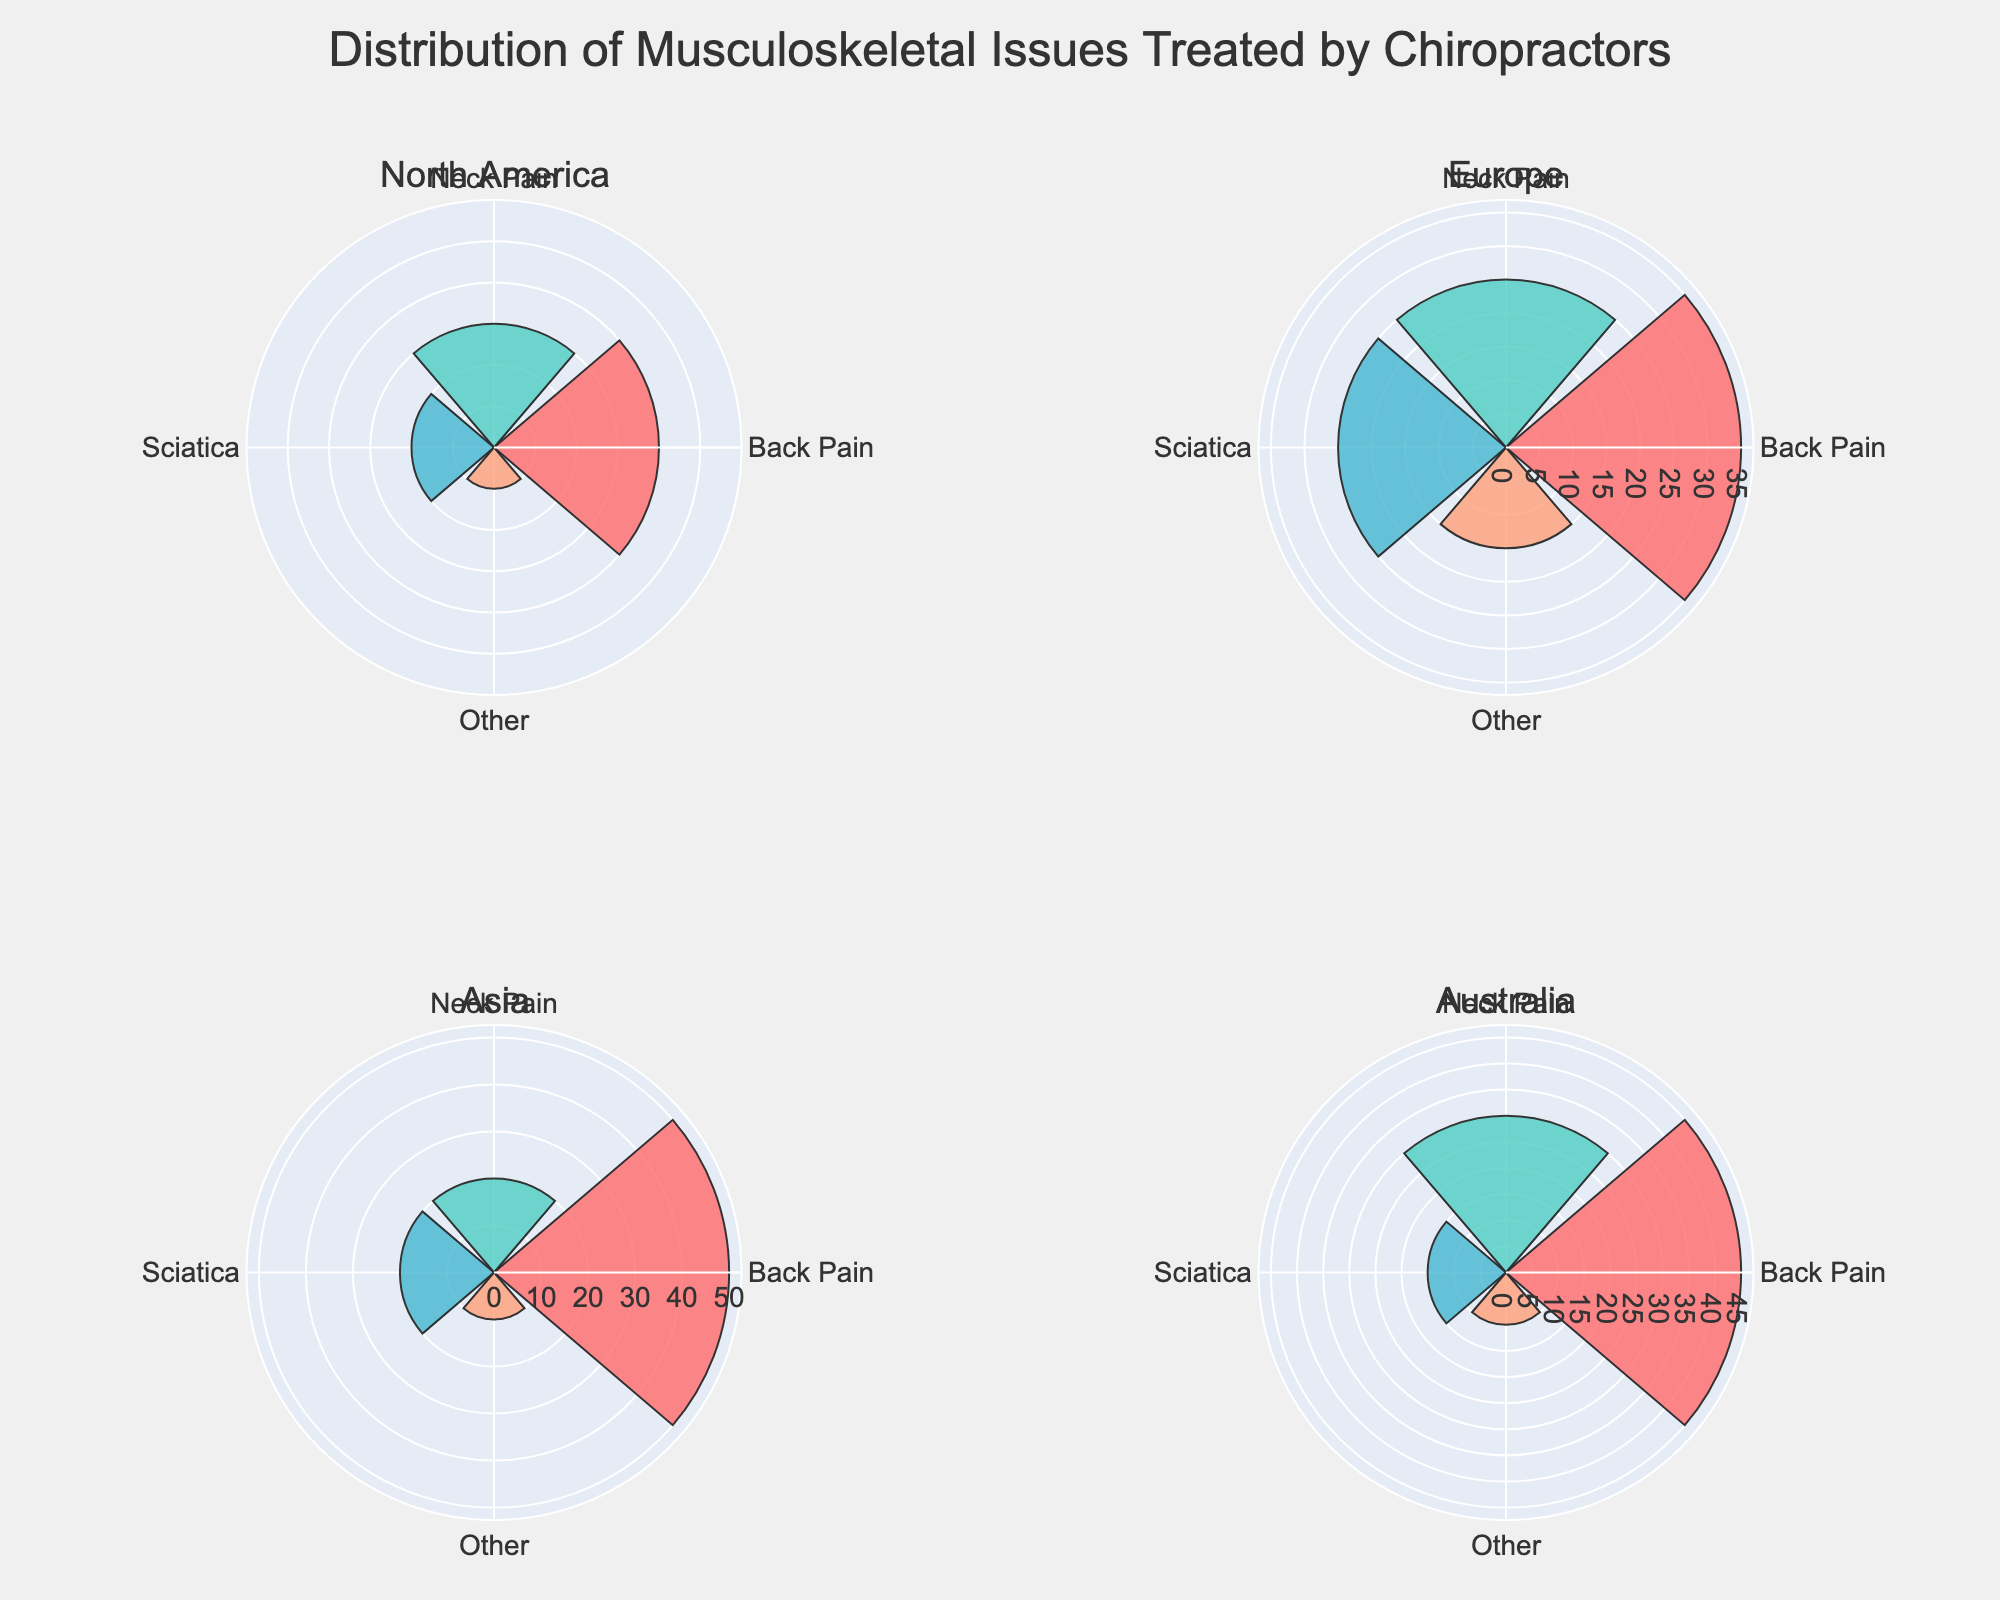What's the most common musculoskeletal issue treated by chiropractors in North America? The North America subplot shows four sections of the rose chart: Back Pain, Neck Pain, Sciatica, and Other. The largest section is for Back Pain.
Answer: Back Pain Which region has the highest percentage of chiropractors treating Back Pain? By inspecting the rose chart, we can see the section labeled Back Pain is largest in the Asia subplot.
Answer: Asia Compare the percentages of Neck Pain treated by chiropractors in North America and Australia. Which region has a higher percentage? North America has 30% for Neck Pain and Australia also has 30% for Neck Pain. They are equal.
Answer: They are equal What's the total percentage of musculoskeletal issues classified as Other treated by chiropractors in Europe and Asia combined? Europe has 15% classified as Other and Asia has 10%. Summing these percentages gives 15 + 10 = 25%.
Answer: 25% Which condition is treated with a 35% frequency in any region? By checking each subplot, Back Pain in Europe is the condition treated at 35%.
Answer: Back Pain in Europe Identify the region with the least proportion of Sciatica cases. The rose chart shows that in Australia, the Sciatica section is the smallest at 15%.
Answer: Australia What's the difference in the percentage of Back Pain treatments between North America and Europe? North America has 40% and Europe has 35%. The difference is 40 - 35 = 5%.
Answer: 5% If you sum the percentages of Neck Pain and Sciatica in Asia, what do you get? Neck Pain in Asia is 20% and Sciatica in Asia is 20%. Summing these gives 20 + 20 = 40%.
Answer: 40% Which region has the smallest combined percentage for conditions Other and Sciatica? Looking at each subplot, Europe has 15% for Other and 25% for Sciatica, totaling 40%. The smallest combined percentage is in North America with 10% for Other and 20% for Sciatica, totaling 30%.
Answer: North America 